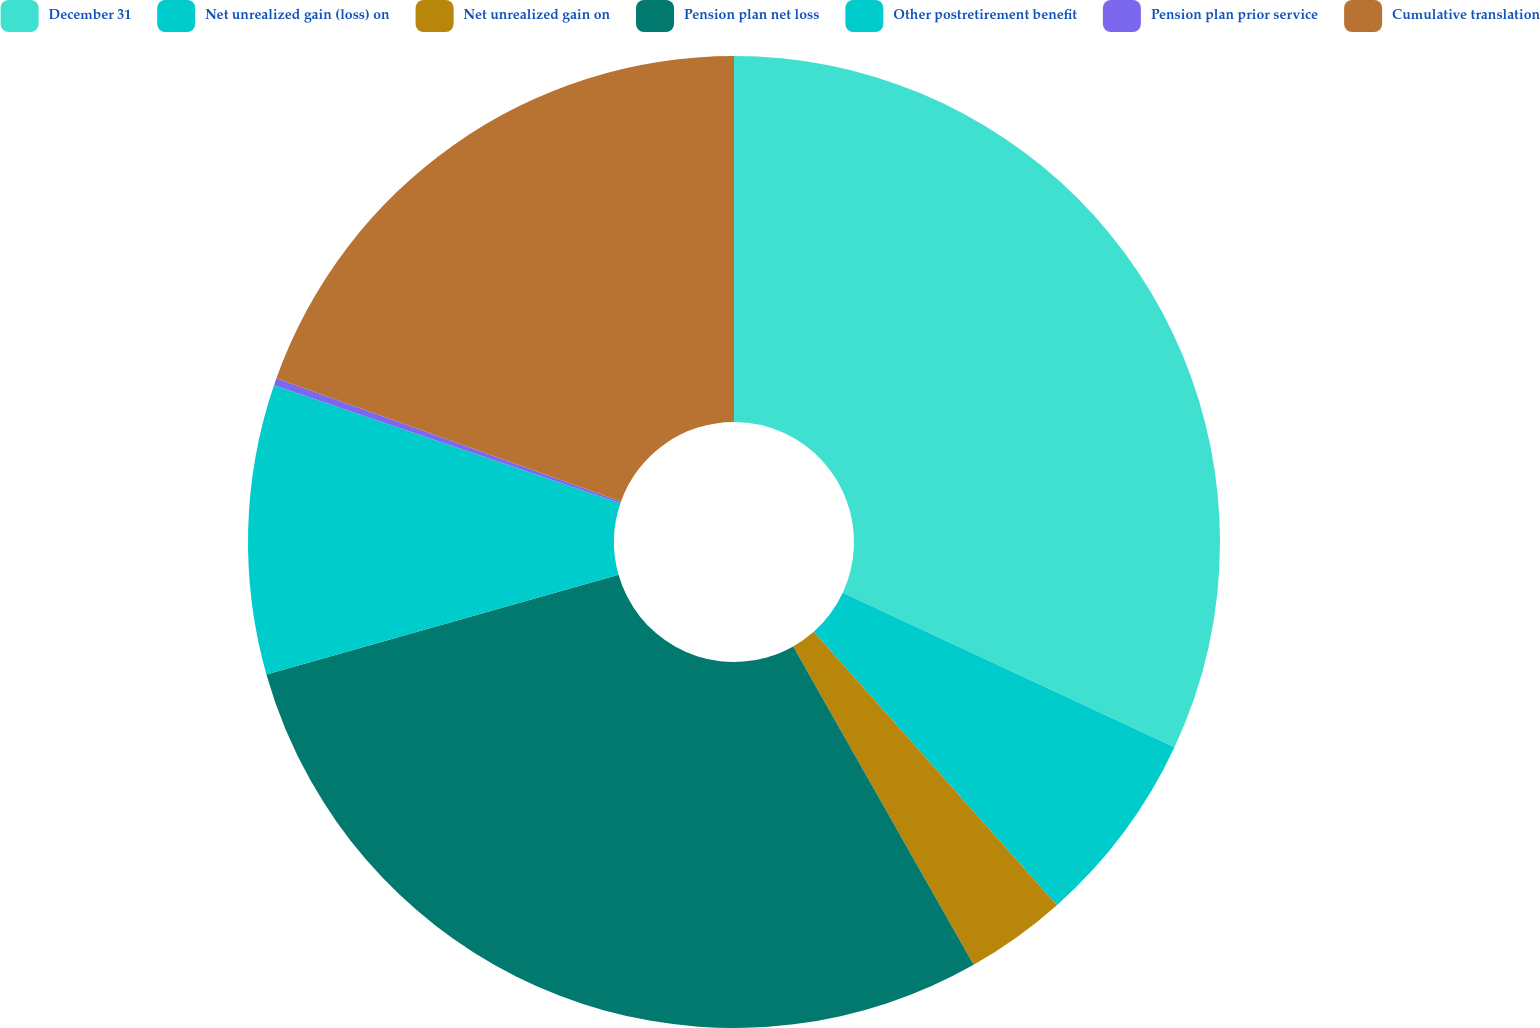Convert chart to OTSL. <chart><loc_0><loc_0><loc_500><loc_500><pie_chart><fcel>December 31<fcel>Net unrealized gain (loss) on<fcel>Net unrealized gain on<fcel>Pension plan net loss<fcel>Other postretirement benefit<fcel>Pension plan prior service<fcel>Cumulative translation<nl><fcel>31.94%<fcel>6.49%<fcel>3.36%<fcel>28.81%<fcel>9.62%<fcel>0.24%<fcel>19.53%<nl></chart> 